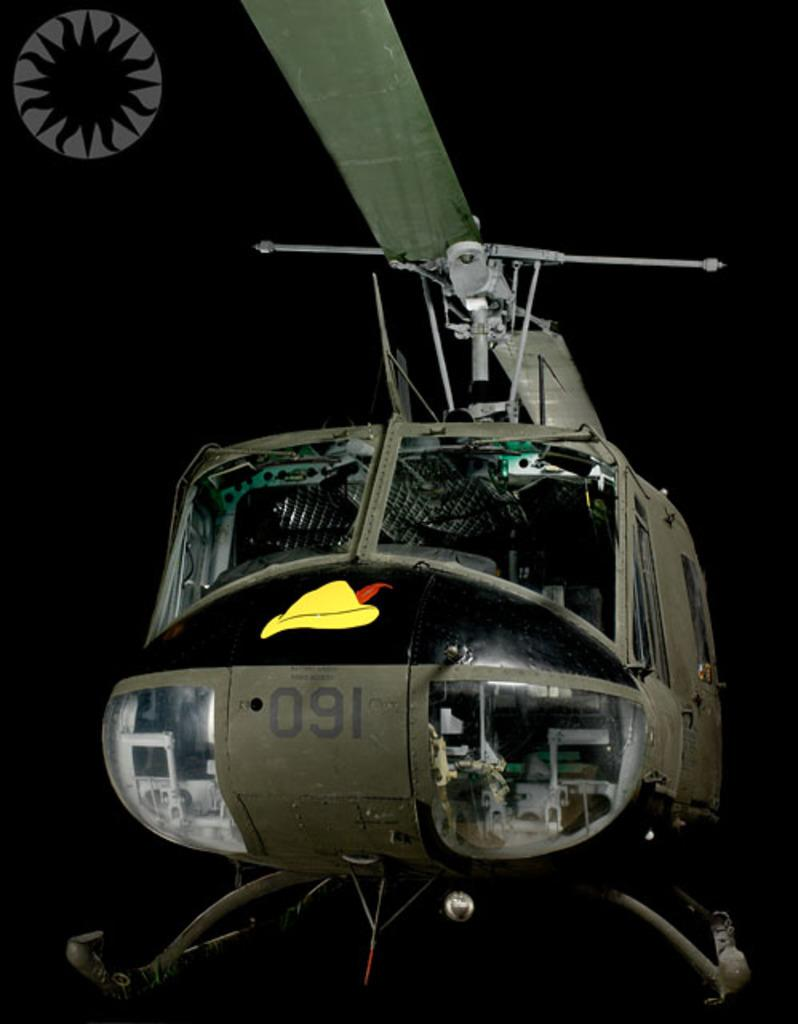Provide a one-sentence caption for the provided image. A disaplay of a grenish brown helicopter with the numbers 091 written on the front. 